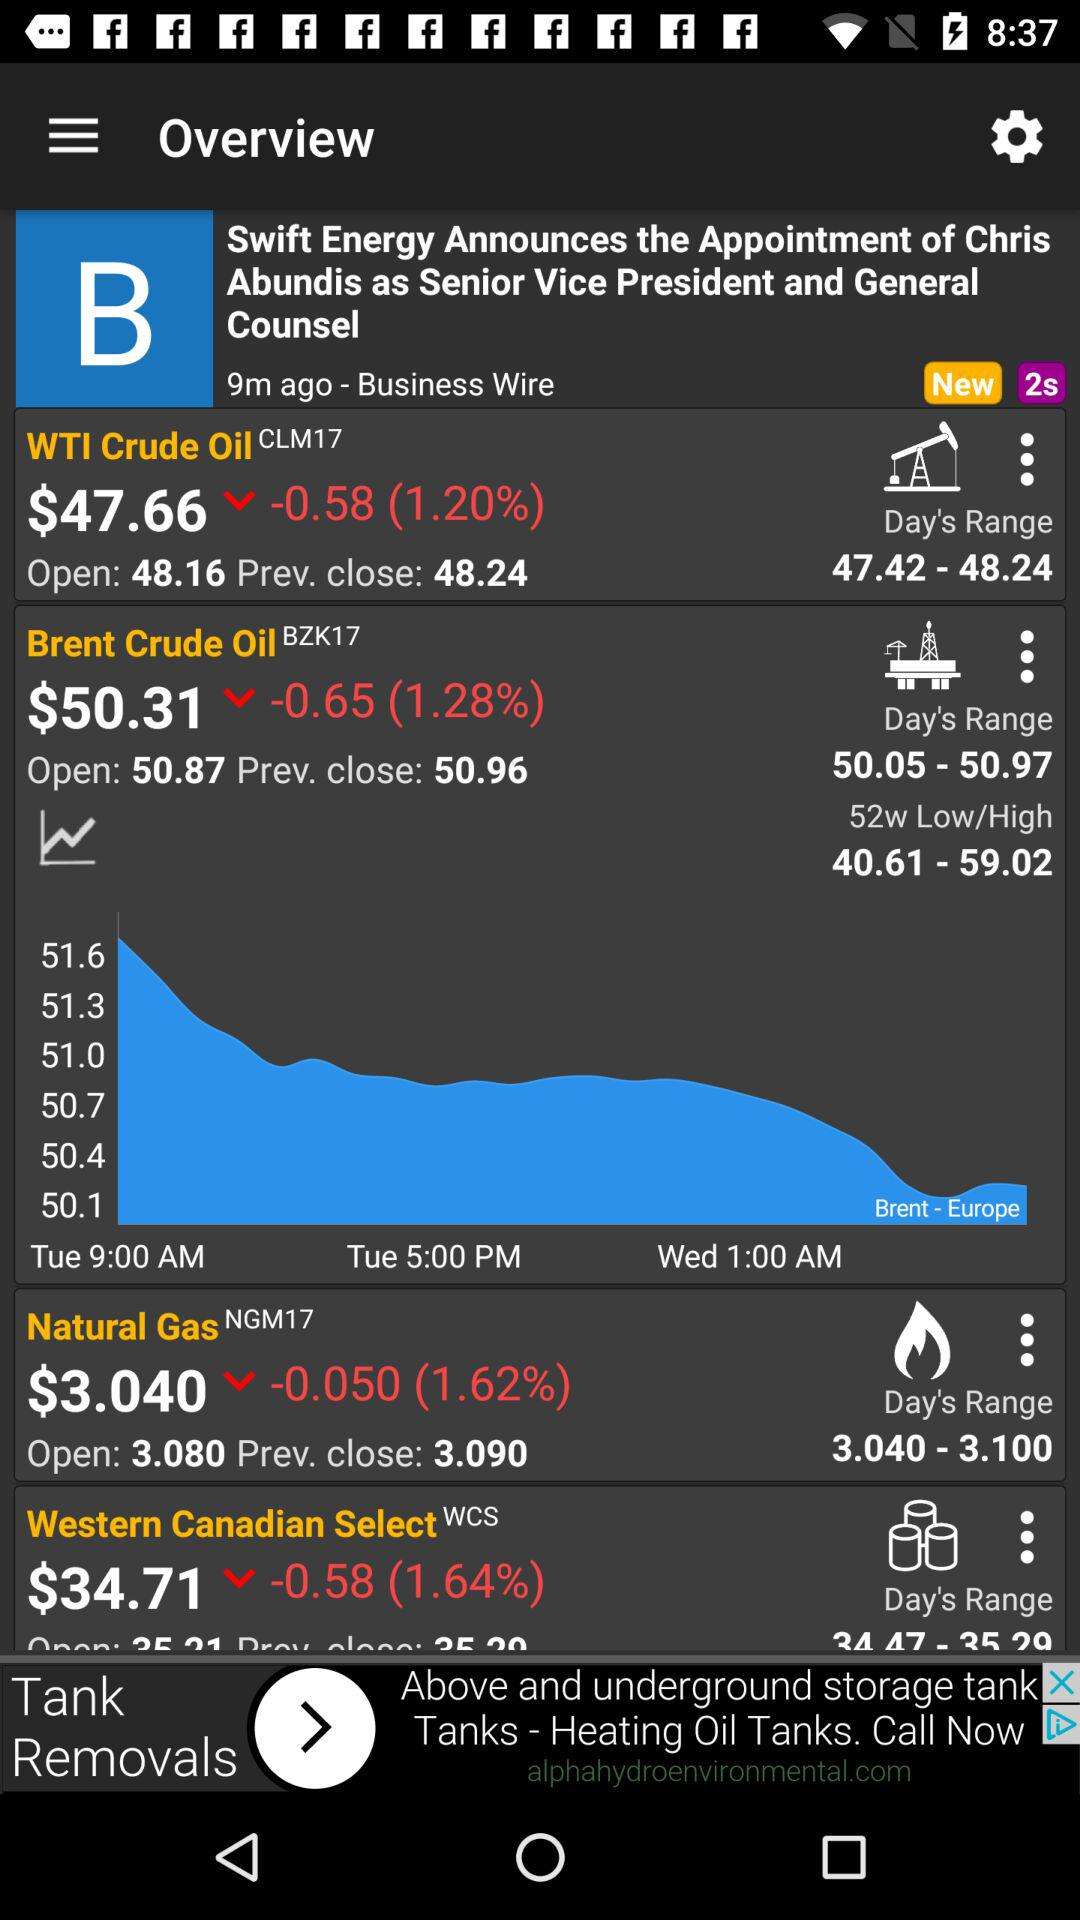How long ago was "Announces the Appointment" posted? It was posted 9 minutes ago. 